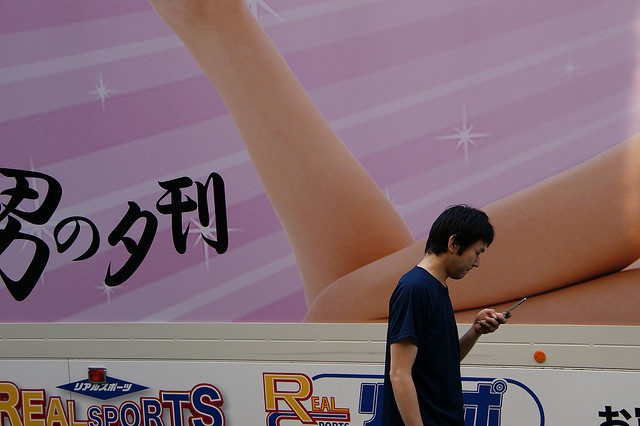Describe the objects in this image and their specific colors. I can see people in purple, black, brown, and maroon tones and cell phone in purple, gray, and black tones in this image. 